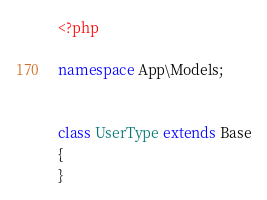<code> <loc_0><loc_0><loc_500><loc_500><_PHP_><?php

namespace App\Models;


class UserType extends Base
{
}
</code> 